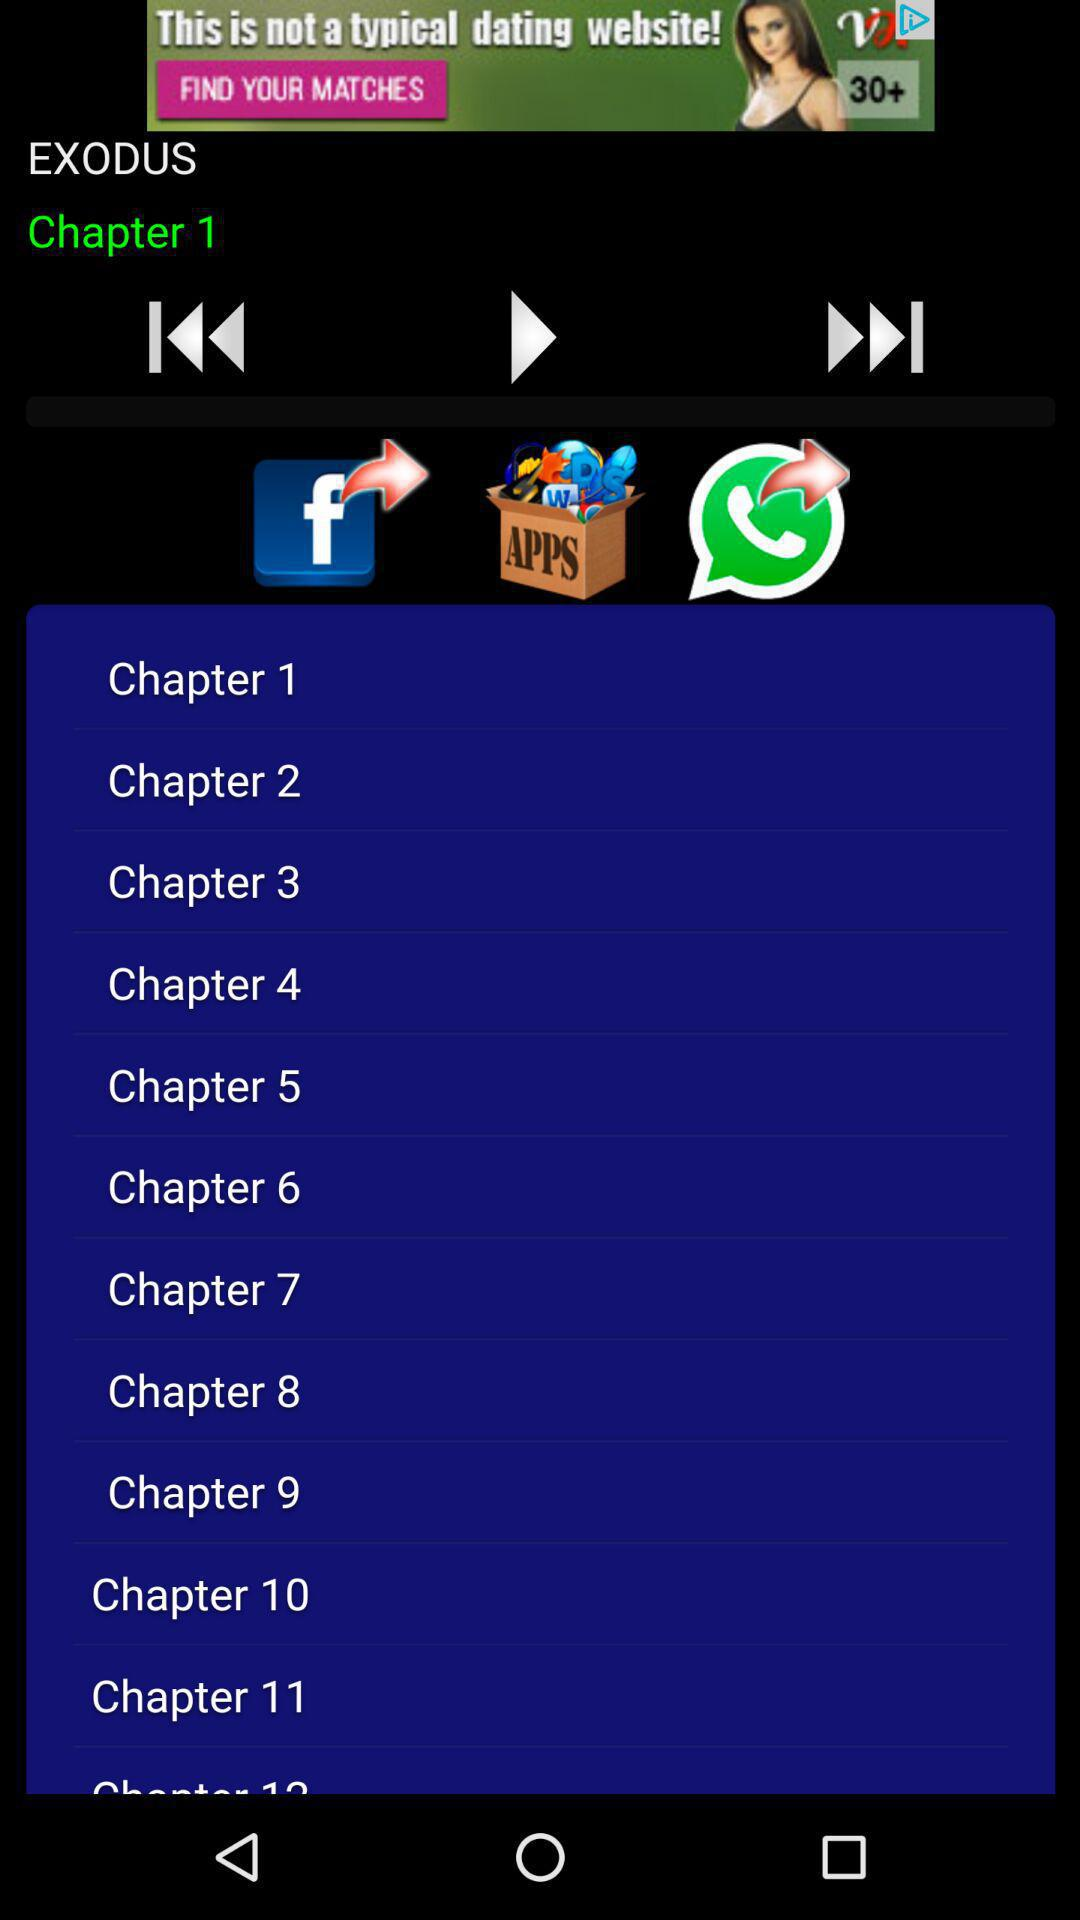Which chapter was last played? The last played chapter was Chapter 1. 